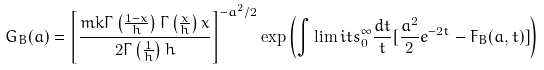Convert formula to latex. <formula><loc_0><loc_0><loc_500><loc_500>G _ { B } ( a ) = \left [ \frac { m k \Gamma \left ( \frac { 1 - x } { h } \right ) \Gamma \left ( \frac { x } { h } \right ) x } { 2 \Gamma \left ( \frac { 1 } { h } \right ) h } \right ] ^ { - a ^ { 2 } / 2 } \exp \left ( \int \lim i t s _ { 0 } ^ { \infty } \frac { d t } { t } [ \frac { a ^ { 2 } } { 2 } e ^ { - 2 t } - F _ { B } ( a , t ) ] \right )</formula> 